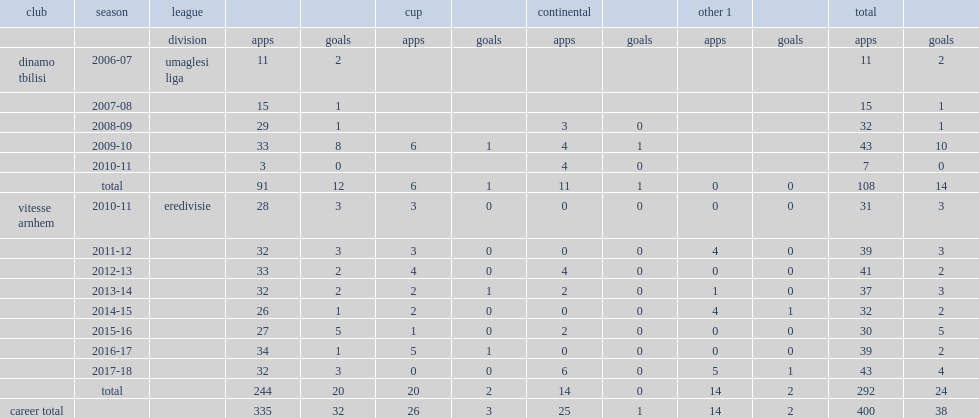How many matches did guram kashia play in vitesse arnhem? 292.0. Can you parse all the data within this table? {'header': ['club', 'season', 'league', '', '', 'cup', '', 'continental', '', 'other 1', '', 'total', ''], 'rows': [['', '', 'division', 'apps', 'goals', 'apps', 'goals', 'apps', 'goals', 'apps', 'goals', 'apps', 'goals'], ['dinamo tbilisi', '2006-07', 'umaglesi liga', '11', '2', '', '', '', '', '', '', '11', '2'], ['', '2007-08', '', '15', '1', '', '', '', '', '', '', '15', '1'], ['', '2008-09', '', '29', '1', '', '', '3', '0', '', '', '32', '1'], ['', '2009-10', '', '33', '8', '6', '1', '4', '1', '', '', '43', '10'], ['', '2010-11', '', '3', '0', '', '', '4', '0', '', '', '7', '0'], ['', 'total', '', '91', '12', '6', '1', '11', '1', '0', '0', '108', '14'], ['vitesse arnhem', '2010-11', 'eredivisie', '28', '3', '3', '0', '0', '0', '0', '0', '31', '3'], ['', '2011-12', '', '32', '3', '3', '0', '0', '0', '4', '0', '39', '3'], ['', '2012-13', '', '33', '2', '4', '0', '4', '0', '0', '0', '41', '2'], ['', '2013-14', '', '32', '2', '2', '1', '2', '0', '1', '0', '37', '3'], ['', '2014-15', '', '26', '1', '2', '0', '0', '0', '4', '1', '32', '2'], ['', '2015-16', '', '27', '5', '1', '0', '2', '0', '0', '0', '30', '5'], ['', '2016-17', '', '34', '1', '5', '1', '0', '0', '0', '0', '39', '2'], ['', '2017-18', '', '32', '3', '0', '0', '6', '0', '5', '1', '43', '4'], ['', 'total', '', '244', '20', '20', '2', '14', '0', '14', '2', '292', '24'], ['career total', '', '', '335', '32', '26', '3', '25', '1', '14', '2', '400', '38']]} 